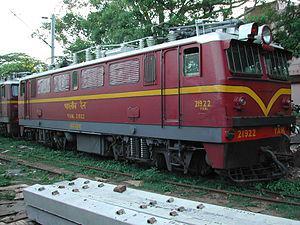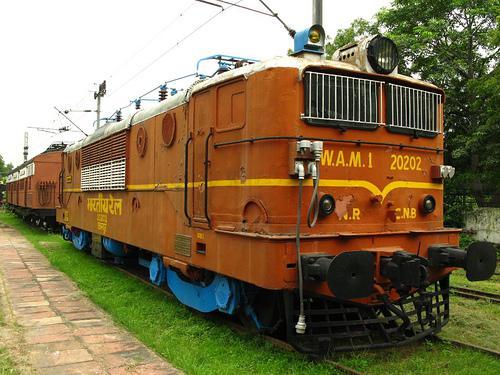The first image is the image on the left, the second image is the image on the right. Analyze the images presented: Is the assertion "A red train with a yellowish stripe running its length is angled facing rightward." valid? Answer yes or no. Yes. The first image is the image on the left, the second image is the image on the right. For the images shown, is this caption "There are two trains going in the same direction, none of which are red." true? Answer yes or no. No. 